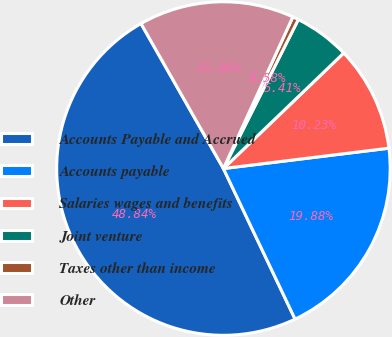Convert chart to OTSL. <chart><loc_0><loc_0><loc_500><loc_500><pie_chart><fcel>Accounts Payable and Accrued<fcel>Accounts payable<fcel>Salaries wages and benefits<fcel>Joint venture<fcel>Taxes other than income<fcel>Other<nl><fcel>48.84%<fcel>19.88%<fcel>10.23%<fcel>5.41%<fcel>0.58%<fcel>15.06%<nl></chart> 